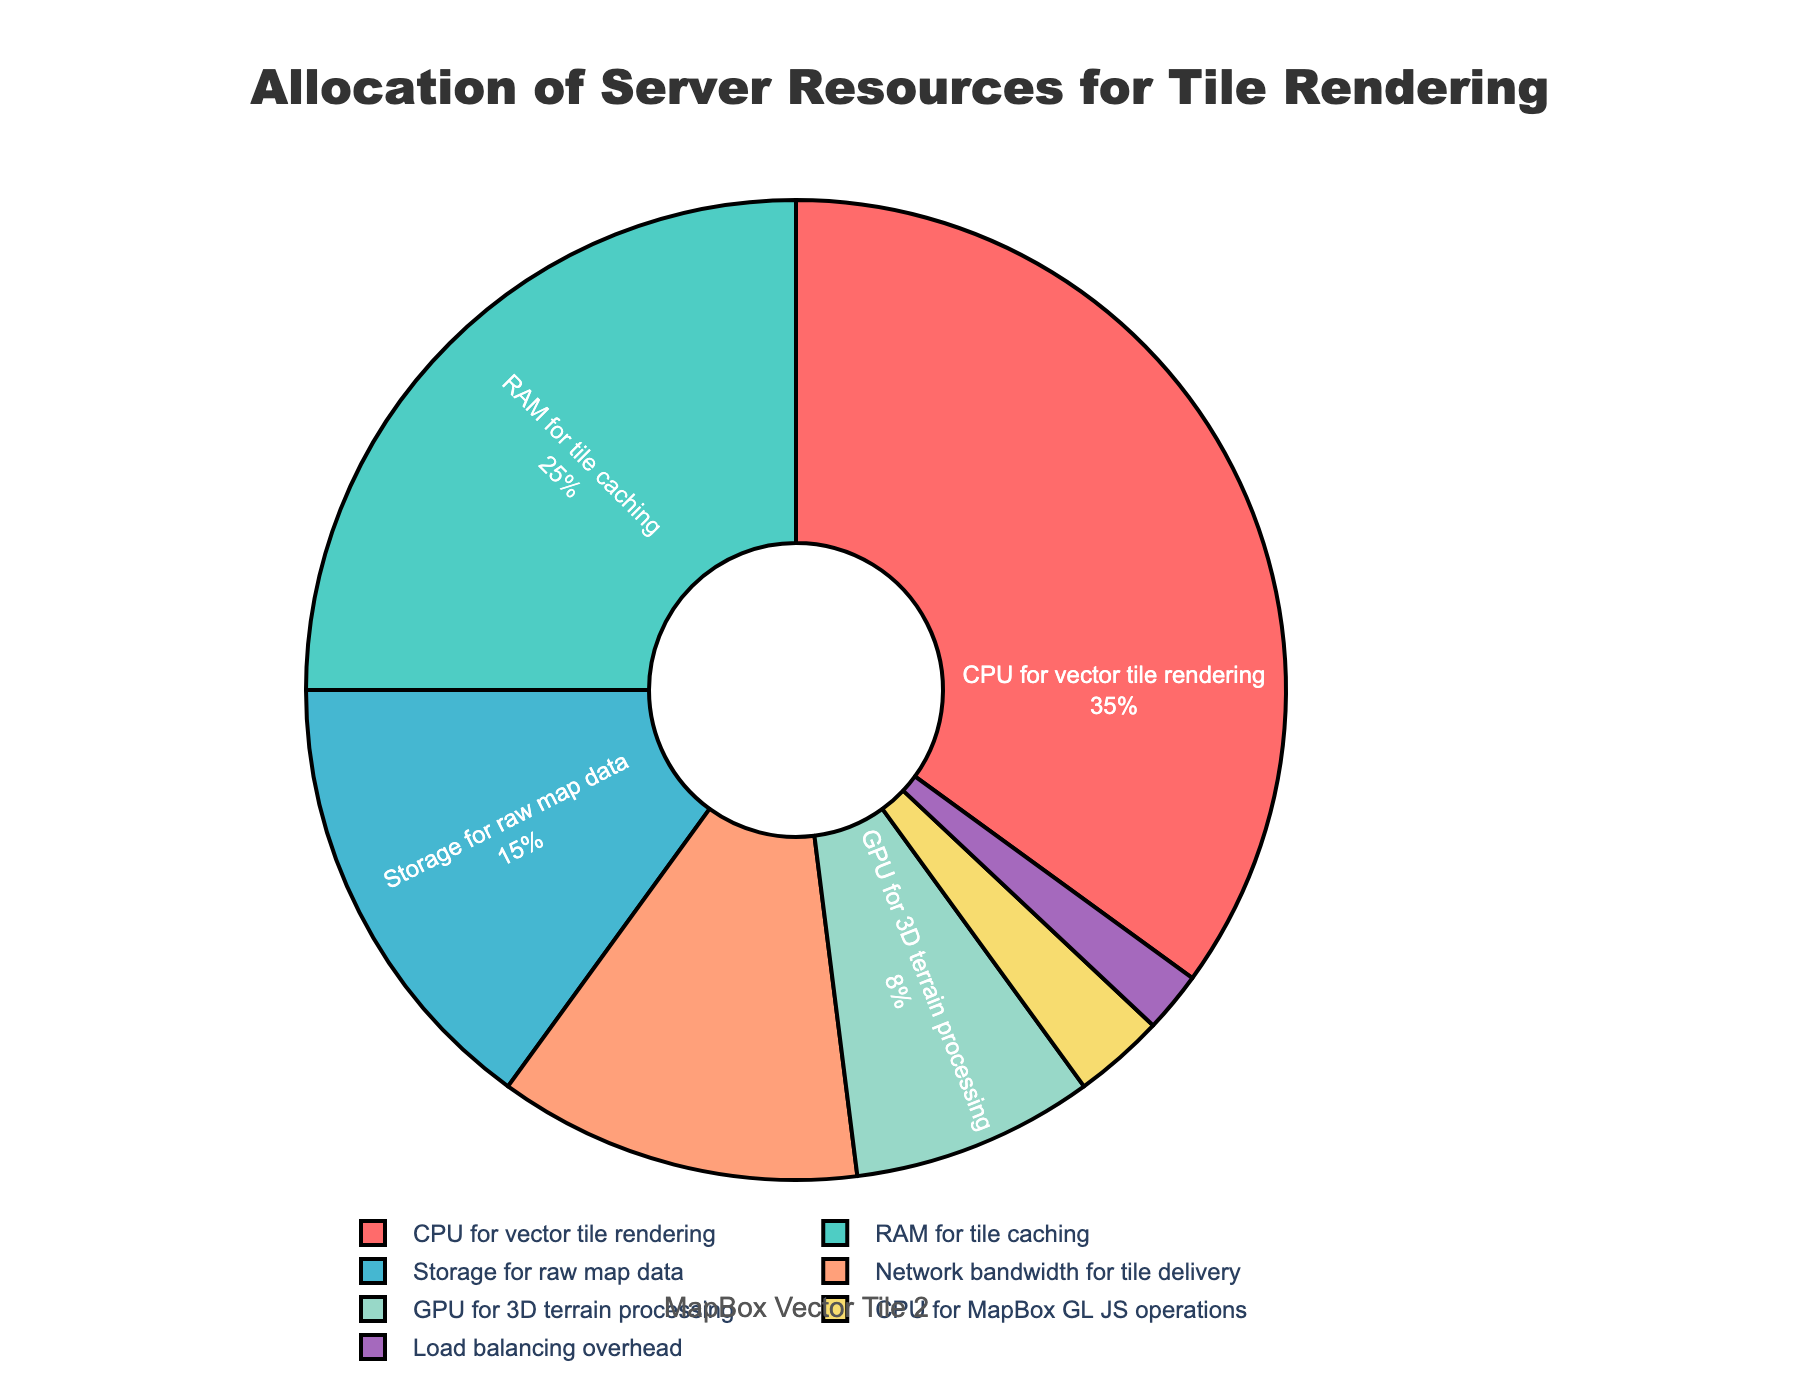Which category has the highest percentage allocation of server resources? To determine the category with the highest allocation, look at the category with the largest slice in the pie chart. The largest slice corresponds to the "CPU for vector tile rendering".
Answer: CPU for vector tile rendering What is the combined percentage allocation for "RAM for tile caching" and "Storage for raw map data"? To find the combined percentage, add the percentages of "RAM for tile caching" (25%) and "Storage for raw map data" (15%). 25% + 15% = 40%.
Answer: 40% Which category has a greater allocation: "Network bandwidth for tile delivery" or "GPU for 3D terrain processing"? Compare the percentages of each category. "Network bandwidth for tile delivery" has 12%, and "GPU for 3D terrain processing" has 8%. Since 12% is greater than 8%, "Network bandwidth for tile delivery" has a greater allocation.
Answer: Network bandwidth for tile delivery If the total server resources were to be increased by 10%, what would be the new percentage allocation for "Load balancing overhead"? First, calculate 10% of the total current allocation of "Load balancing overhead" which is 2%. 10% of 2% is 0.2%. Add this to the original 2%, resulting in 2.2%.
Answer: 2.2% How much more allocation does "CPU for MapBox GL JS operations" need to equal the allocation of "GPU for 3D terrain processing"? Subtract the current allocation of "CPU for MapBox GL JS operations" (3%) from the allocation of "GPU for 3D terrain processing" (8%). 8% - 3% = 5%. "CPU for MapBox GL JS operations" needs 5% more to match the allocation of "GPU for 3D terrain processing".
Answer: 5% What is the percentage difference between the allocations for "CPU for vector tile rendering" and "RAM for tile caching"? Subtract the smaller percentage (RAM for tile caching, 25%) from the larger percentage (CPU for vector tile rendering, 35%). 35% - 25% = 10%. The percentage difference is 10%.
Answer: 10% Which allocations can be combined to equal 50% of the server resources? Look for combinations whose sums equal 50%. One possible combination is "CPU for vector tile rendering" (35%) + "RAM for tile caching" (25%) = 60%. Another combination is "RAM for tile caching" (25%) + "Storage for raw map data" (15%) + "Network bandwidth for tile delivery" (12%) = 52%. Similar combinations can be verified visually for an exact match or a close approximation to 50%. A closer visual inspection could help find exact fits.
Answer: Multiple possible combinations What color represents "Storage for raw map data"? Identify the slice corresponding to "Storage for raw map data" in the pie chart. It is visually represented by a specific color, which is light orange.
Answer: Light orange What fraction of the server resources is allocated to "Load balancing overhead" compared to the total resources? Convert the percentage of "Load balancing overhead" (2%) into a fraction compared to the total of 100%. 2% out of 100% is equivalent to 2/100 or 1/50.
Answer: 1/50 What is the visual representation style used for the labels inside the pie chart slices? Describe the text style by observing the labels inside the slices. The labels show the category and percentage in white text, with a radial orientation.
Answer: Radial orientation, white text 